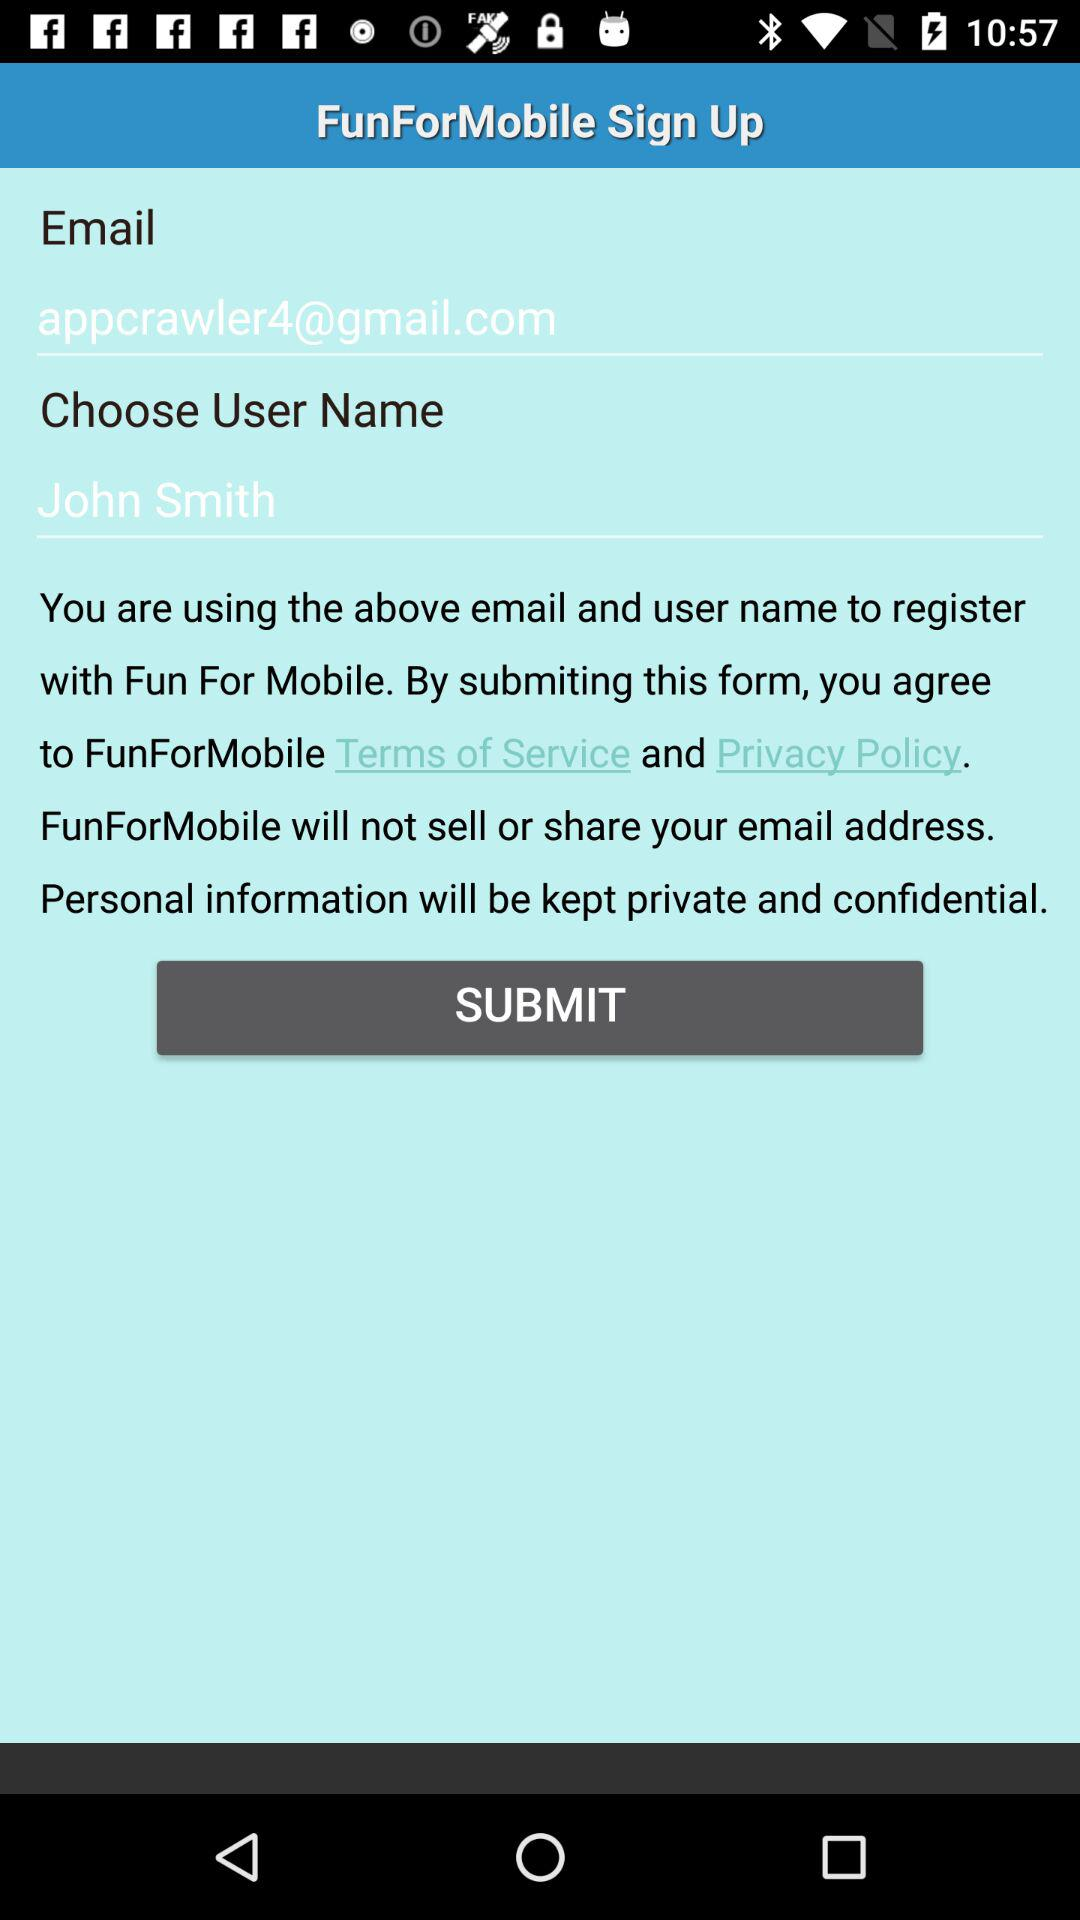What is the email address? The email address is "appcrawler4@gmail.com". 